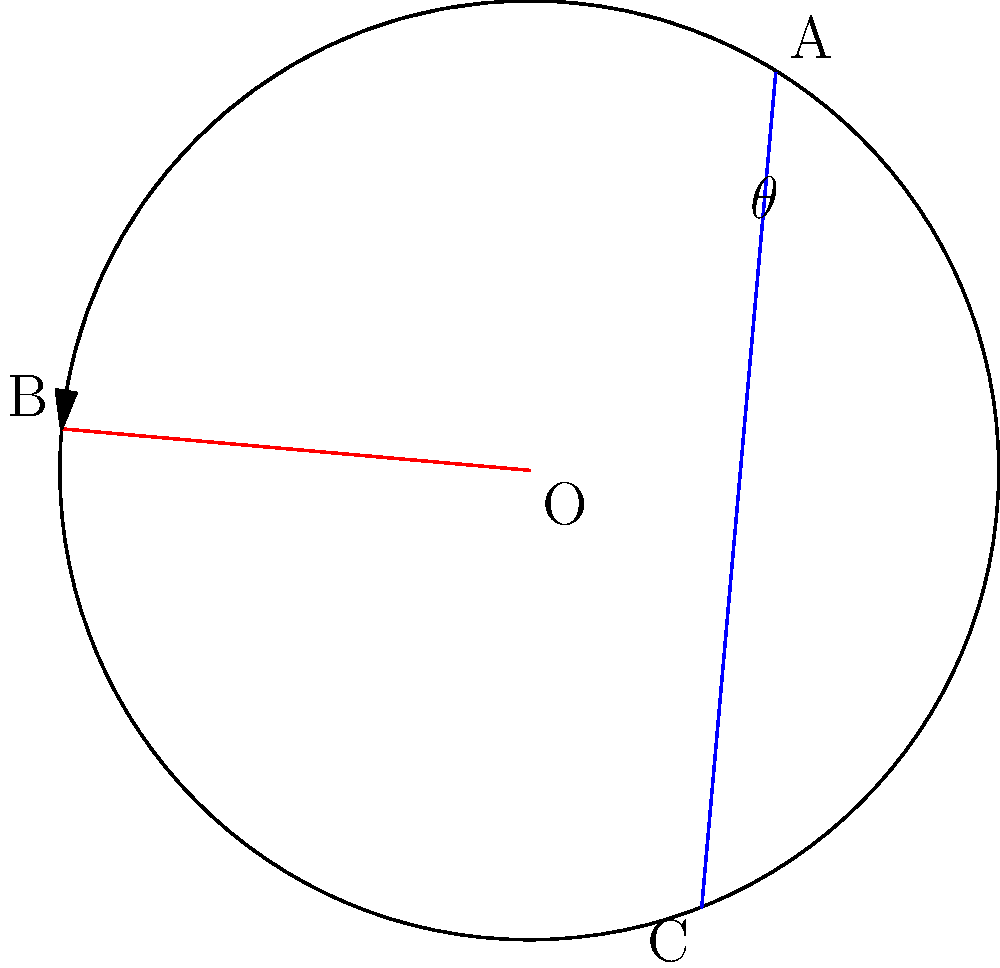On a classic rock vinyl record, two grooves intersect at the center O. If the angle BOA is $45^\circ$ and the line AC passes through the center O, what is the measure of angle $\theta$ between the two intersecting grooves? Let's approach this step-by-step:

1) First, note that BOA is given as $45^\circ$.

2) In a circle, the angle between a tangent and a chord at the point of contact is equal to the angle in the alternate segment. Here, OB is a radius and thus perpendicular to the tangent at B. So, angle CBO = $45^\circ$.

3) Triangle BOC is isosceles because OB and OC are radii of the circle. Therefore, angle OCB = angle CBO = $45^\circ$.

4) The sum of angles in a triangle is $180^\circ$. So in triangle BOC:
   $\angle BOC + \angle CBO + \angle OCB = 180^\circ$
   $\angle BOC + 45^\circ + 45^\circ = 180^\circ$
   $\angle BOC = 90^\circ$

5) The angle we're looking for, $\theta$, is half of $\angle BOC$ because the diameter AC bisects $\angle BOC$.

6) Therefore, $\theta = \frac{1}{2} \times 90^\circ = 45^\circ$
Answer: $45^\circ$ 